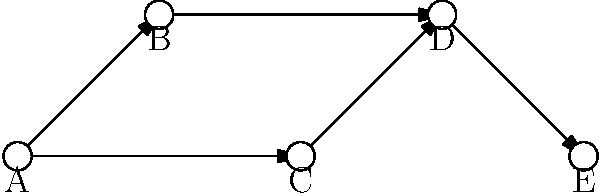As a project manager, you've created a network graph to visualize communication patterns among your team members (A, B, C, D, and E). Each arrow represents the direction of information flow. Based on this graph, which team member appears to be the central point of communication, receiving information from multiple sources and distributing it further? To determine the central point of communication, we need to analyze the incoming and outgoing connections for each team member:

1. Team member A: 
   - Outgoing connections: 2 (to B and C)
   - Incoming connections: 0

2. Team member B:
   - Outgoing connections: 1 (to D)
   - Incoming connections: 1 (from A)

3. Team member C:
   - Outgoing connections: 1 (to D)
   - Incoming connections: 1 (from A)

4. Team member D:
   - Outgoing connections: 1 (to E)
   - Incoming connections: 2 (from B and C)

5. Team member E:
   - Outgoing connections: 0
   - Incoming connections: 1 (from D)

Team member D has the highest number of incoming connections (2) and also has an outgoing connection. This indicates that D receives information from multiple sources (B and C) and distributes it further (to E), making D the central point of communication in this network.
Answer: D 